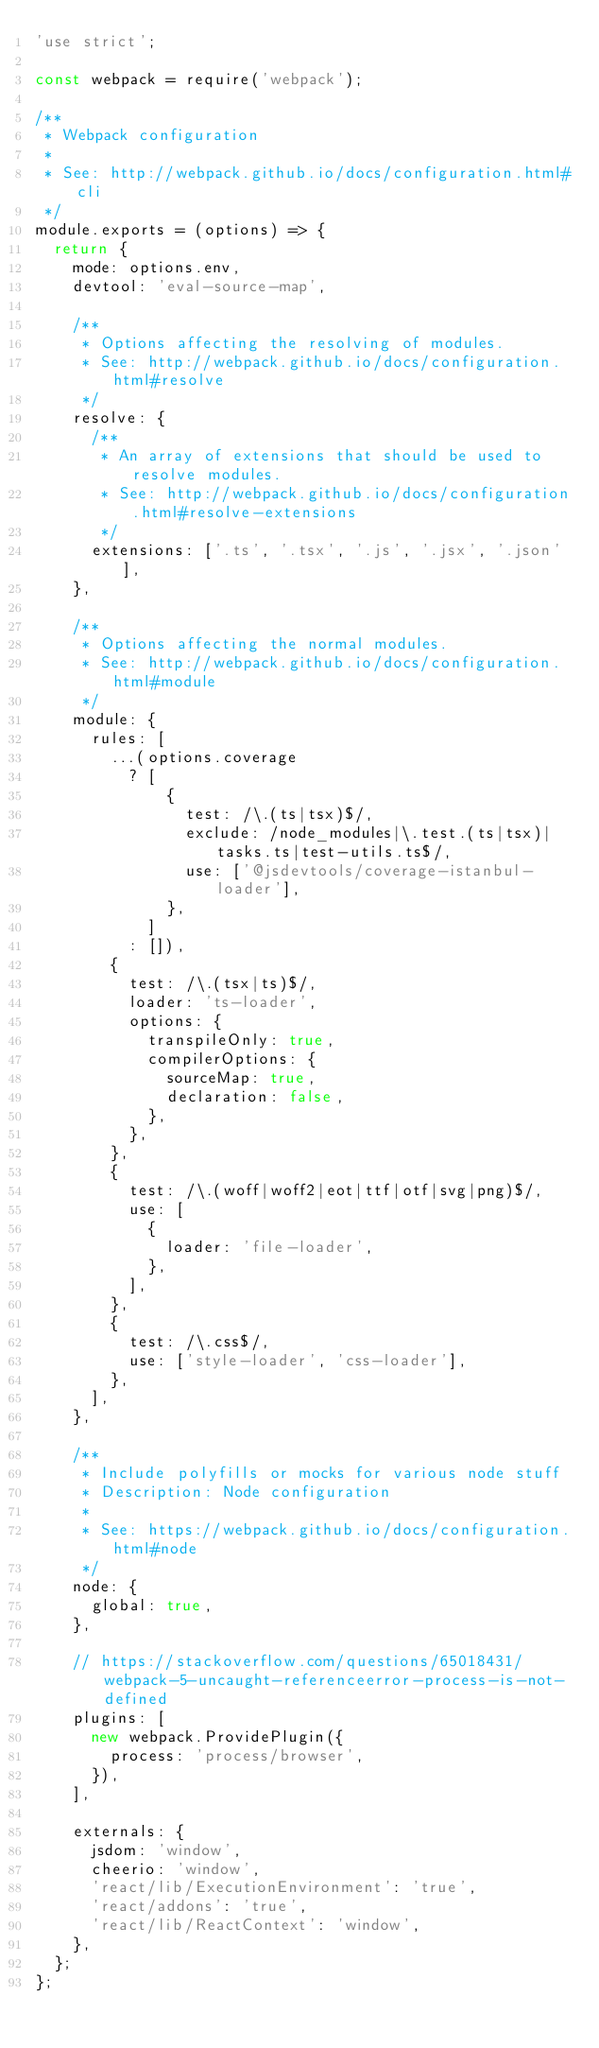<code> <loc_0><loc_0><loc_500><loc_500><_JavaScript_>'use strict';

const webpack = require('webpack');

/**
 * Webpack configuration
 *
 * See: http://webpack.github.io/docs/configuration.html#cli
 */
module.exports = (options) => {
  return {
    mode: options.env,
    devtool: 'eval-source-map',

    /**
     * Options affecting the resolving of modules.
     * See: http://webpack.github.io/docs/configuration.html#resolve
     */
    resolve: {
      /**
       * An array of extensions that should be used to resolve modules.
       * See: http://webpack.github.io/docs/configuration.html#resolve-extensions
       */
      extensions: ['.ts', '.tsx', '.js', '.jsx', '.json'],
    },

    /**
     * Options affecting the normal modules.
     * See: http://webpack.github.io/docs/configuration.html#module
     */
    module: {
      rules: [
        ...(options.coverage
          ? [
              {
                test: /\.(ts|tsx)$/,
                exclude: /node_modules|\.test.(ts|tsx)|tasks.ts|test-utils.ts$/,
                use: ['@jsdevtools/coverage-istanbul-loader'],
              },
            ]
          : []),
        {
          test: /\.(tsx|ts)$/,
          loader: 'ts-loader',
          options: {
            transpileOnly: true,
            compilerOptions: {
              sourceMap: true,
              declaration: false,
            },
          },
        },
        {
          test: /\.(woff|woff2|eot|ttf|otf|svg|png)$/,
          use: [
            {
              loader: 'file-loader',
            },
          ],
        },
        {
          test: /\.css$/,
          use: ['style-loader', 'css-loader'],
        },
      ],
    },

    /**
     * Include polyfills or mocks for various node stuff
     * Description: Node configuration
     *
     * See: https://webpack.github.io/docs/configuration.html#node
     */
    node: {
      global: true,
    },

    // https://stackoverflow.com/questions/65018431/webpack-5-uncaught-referenceerror-process-is-not-defined
    plugins: [
      new webpack.ProvidePlugin({
        process: 'process/browser',
      }),
    ],

    externals: {
      jsdom: 'window',
      cheerio: 'window',
      'react/lib/ExecutionEnvironment': 'true',
      'react/addons': 'true',
      'react/lib/ReactContext': 'window',
    },
  };
};
</code> 